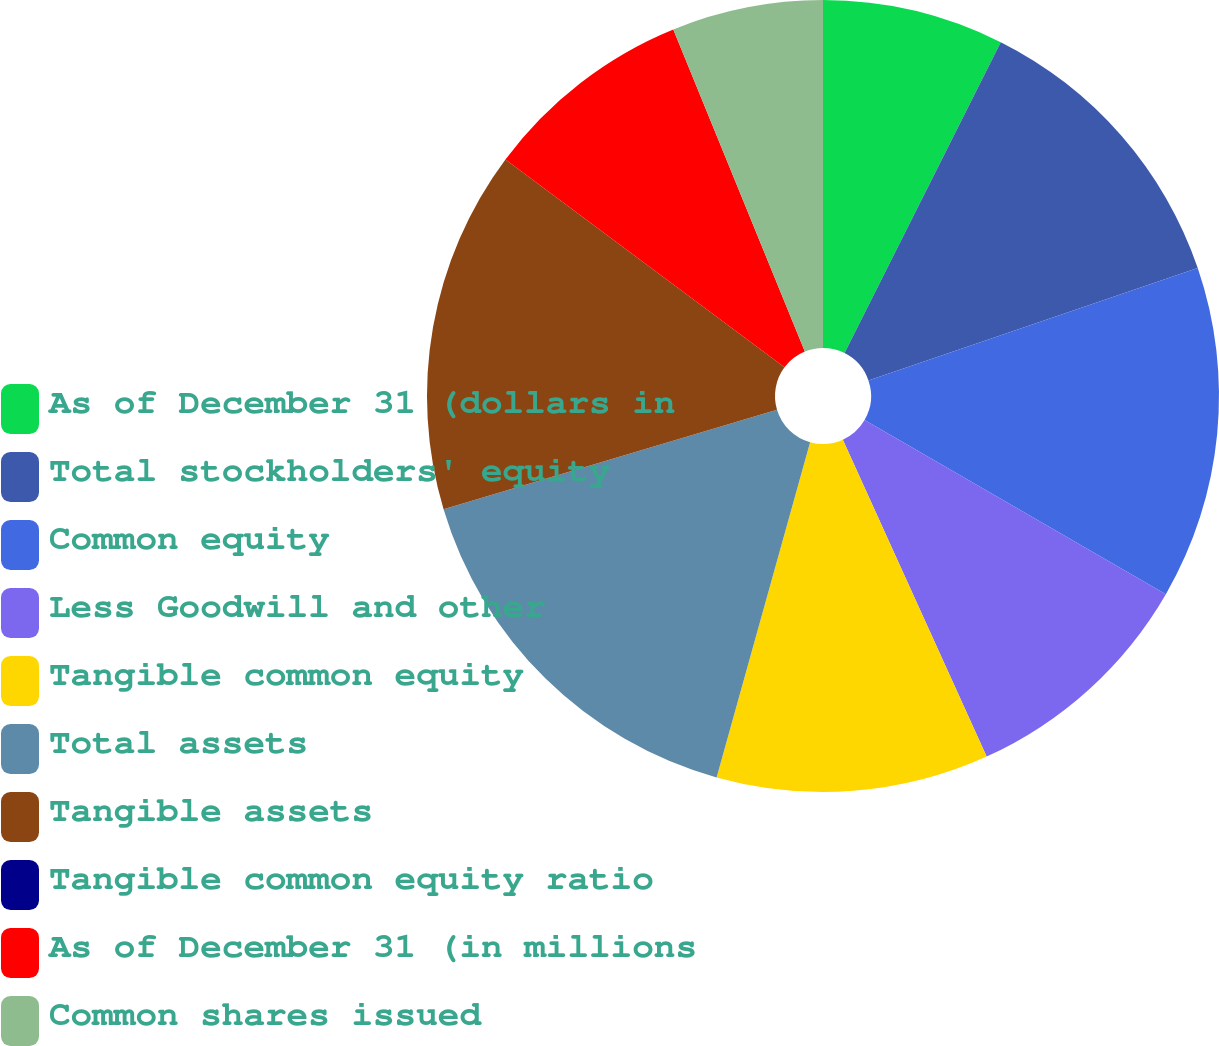<chart> <loc_0><loc_0><loc_500><loc_500><pie_chart><fcel>As of December 31 (dollars in<fcel>Total stockholders' equity<fcel>Common equity<fcel>Less Goodwill and other<fcel>Tangible common equity<fcel>Total assets<fcel>Tangible assets<fcel>Tangible common equity ratio<fcel>As of December 31 (in millions<fcel>Common shares issued<nl><fcel>7.41%<fcel>12.35%<fcel>13.58%<fcel>9.88%<fcel>11.11%<fcel>16.05%<fcel>14.81%<fcel>0.0%<fcel>8.64%<fcel>6.17%<nl></chart> 